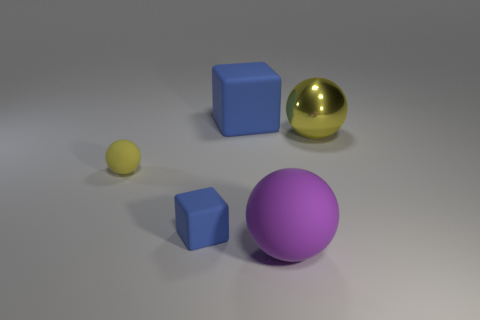There is a small block that is the same material as the big purple thing; what is its color?
Provide a succinct answer. Blue. Is the number of yellow balls that are behind the large purple rubber object the same as the number of small spheres?
Provide a short and direct response. No. There is a blue thing that is the same size as the metal ball; what shape is it?
Offer a very short reply. Cube. How many other objects are there of the same shape as the small blue matte object?
Provide a succinct answer. 1. There is a purple rubber ball; does it have the same size as the blue rubber cube to the left of the large block?
Provide a short and direct response. No. What number of objects are either blocks to the right of the tiny yellow matte sphere or large rubber blocks?
Give a very brief answer. 2. What shape is the large object right of the large purple matte object?
Offer a terse response. Sphere. Is the number of tiny blue matte objects that are behind the small rubber cube the same as the number of matte balls that are in front of the big purple rubber ball?
Give a very brief answer. Yes. There is a large object that is behind the purple ball and in front of the large blue block; what is its color?
Your answer should be compact. Yellow. What material is the large sphere that is behind the big object in front of the tiny blue thing?
Offer a terse response. Metal. 